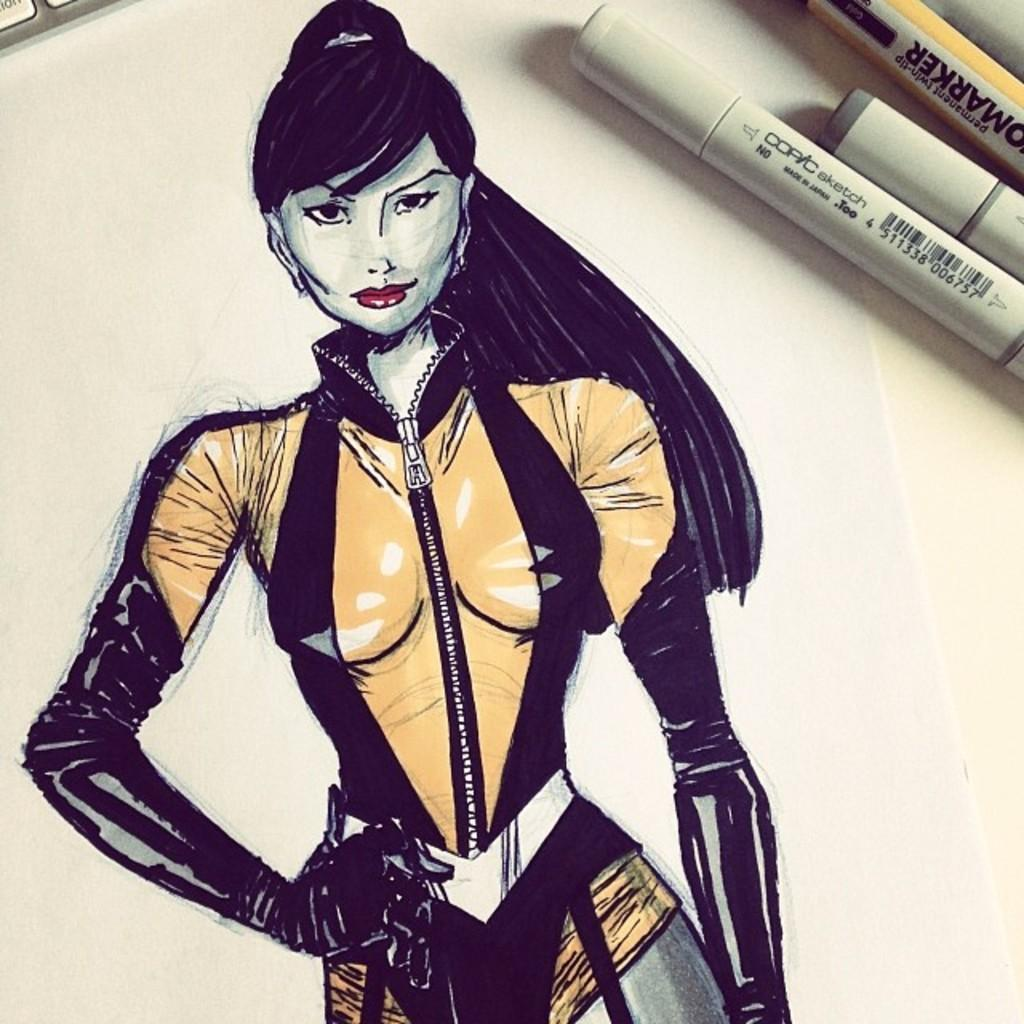What is depicted on the paper in the image? There is a sketch of a lady on the paper. What items are present on the table in the image? There are markers placed on the table. How does the sketch of the lady contribute to the digestion process in the image? The sketch of the lady does not contribute to any digestion process, as it is a drawing on paper and not related to digestion. 